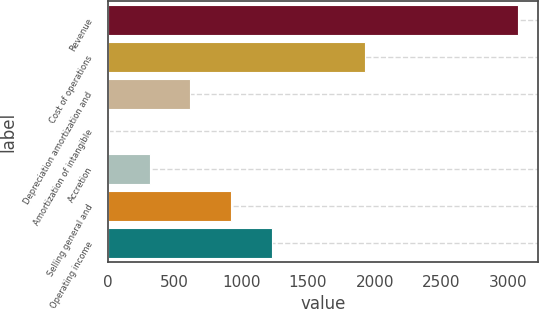Convert chart to OTSL. <chart><loc_0><loc_0><loc_500><loc_500><bar_chart><fcel>Revenue<fcel>Cost of operations<fcel>Depreciation amortization and<fcel>Amortization of intangible<fcel>Accretion<fcel>Selling general and<fcel>Operating income<nl><fcel>3070.6<fcel>1924.4<fcel>619.72<fcel>7<fcel>313.36<fcel>926.08<fcel>1232.44<nl></chart> 